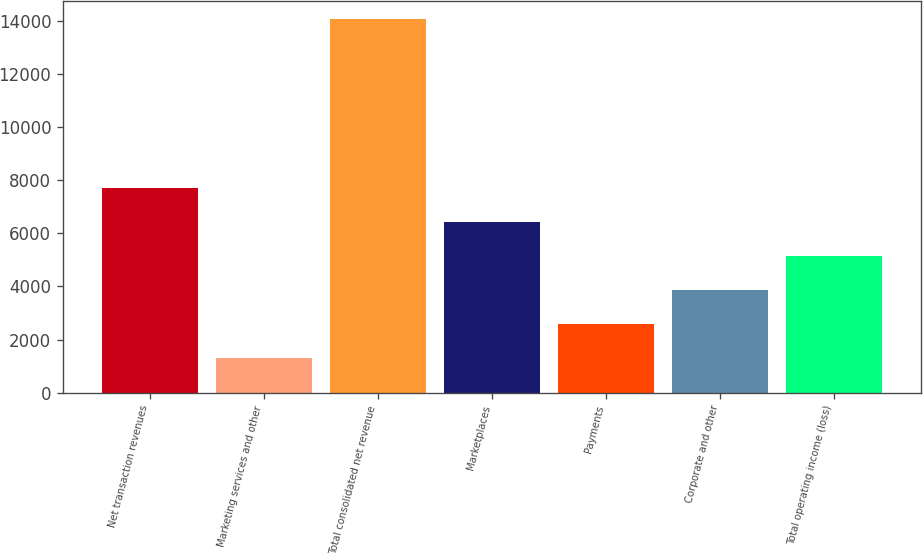Convert chart to OTSL. <chart><loc_0><loc_0><loc_500><loc_500><bar_chart><fcel>Net transaction revenues<fcel>Marketing services and other<fcel>Total consolidated net revenue<fcel>Marketplaces<fcel>Payments<fcel>Corporate and other<fcel>Total operating income (loss)<nl><fcel>7696<fcel>1320<fcel>14072<fcel>6420.8<fcel>2595.2<fcel>3870.4<fcel>5145.6<nl></chart> 